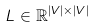Convert formula to latex. <formula><loc_0><loc_0><loc_500><loc_500>L \in \mathbb { R } ^ { | V | \times | V | }</formula> 